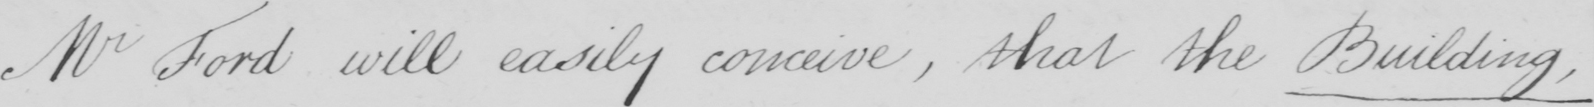What does this handwritten line say? Mr Ford will easily conceive  , that the Building , 